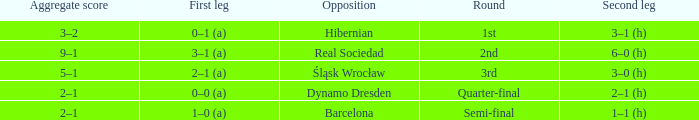What was the first leg score against Real Sociedad? 3–1 (a). 